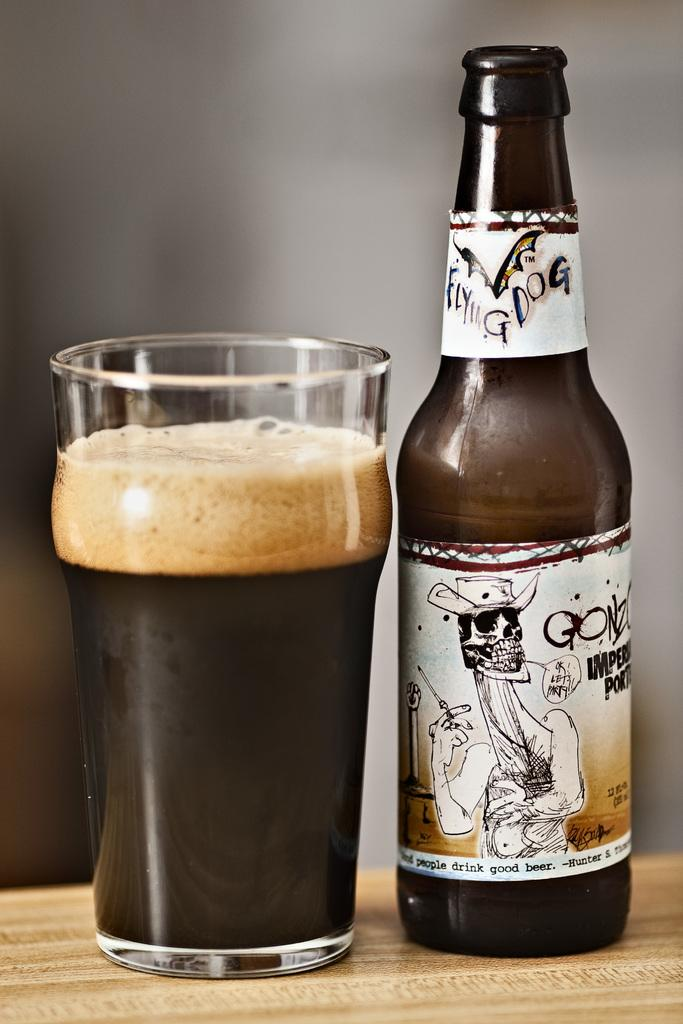What type of table is in the image? There is a wooden table in the image. What is on the table? There is a glass and a bottle on the table. Can you describe the bottle in the image? The bottle has a blurred background. What year is depicted in the image? There is no specific year depicted in the image; it is a still image of a wooden table with a glass and a bottle on it. 